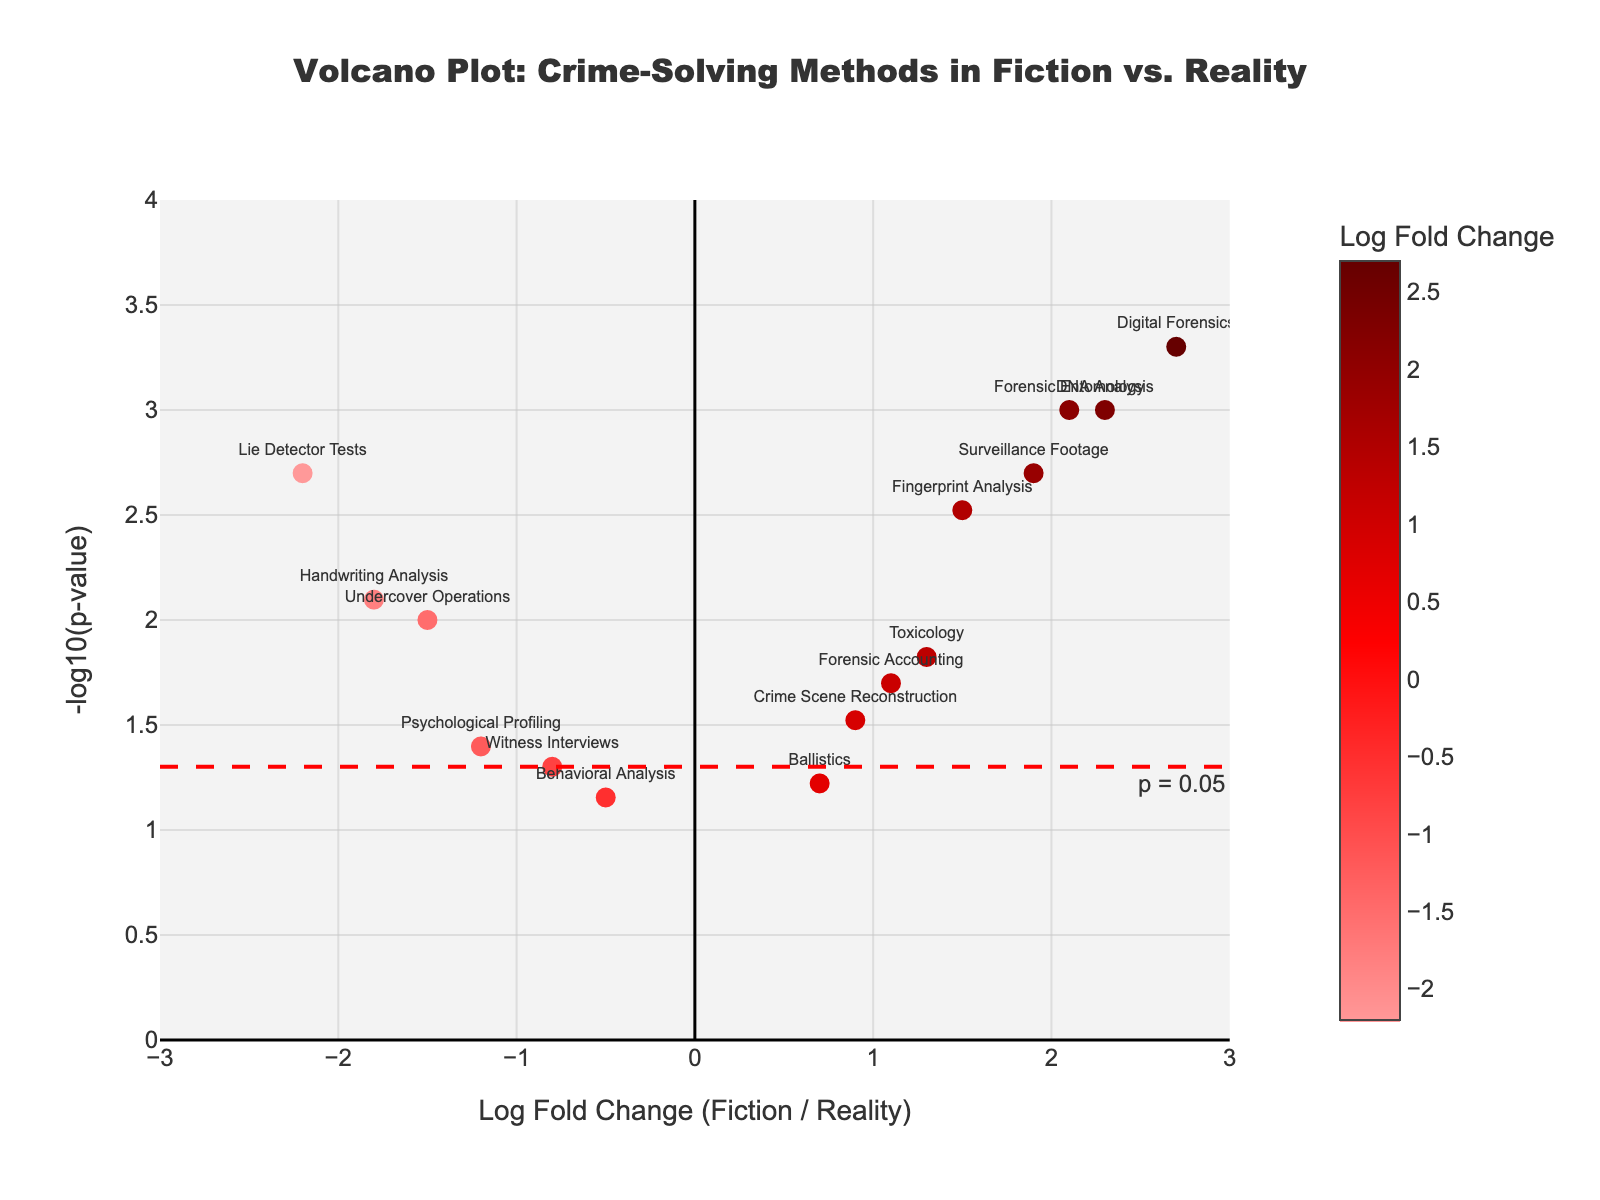What is the title of the plot? The title of the plot is displayed prominently at the top center of the figure. It reads "Volcano Plot: Crime-Solving Methods in Fiction vs. Reality".
Answer: Volcano Plot: Crime-Solving Methods in Fiction vs. Reality How many crime-solving methods are displayed in the plot? By counting the number of data points (markers) labeled with different methods on the plot, we see there are 14 different methods.
Answer: 14 Which crime-solving method has the highest log fold change? The highest log fold change can be identified by locating the data point farthest to the right on the x-axis. This corresponds to "Digital Forensics" with a log fold change of 2.7.
Answer: Digital Forensics What is the p-value threshold indicated by the horizontal line, and what does it signify? The horizontal dashed line is at y = -log10(p-value) = -log10(0.05). This equals 1.3. It signifies the cutoff for determining significant methods: values above this line are statistically significant.
Answer: 0.05 Which method is plotted with the lowest log fold change and what is its value? The lowest log fold change is observed by locating the data point farthest to the left on the x-axis, which is "Lie Detector Tests" with a log fold change of -2.2.
Answer: Lie Detector Tests, -2.2 How many methods have statistically significant p-values (p < 0.05)? By identifying the data points above the y = 1.3 line, we count the methods that have -log10(p-value) > 1.3. There are 11 such methods.
Answer: 11 Which method has the highest -log10(p-value) and what is its value? The highest -log10(p-value) is found by locating the highest data point on the y-axis, which is "Digital Forensics" with a -log10(p-value) of 3.30.
Answer: Digital Forensics, 3.30 Compare the log fold changes and significance of "Fingerprint Analysis" and "Surveillance Footage". Which is more significant and which has a higher fold change? By checking the positions of "Fingerprint Analysis" and "Surveillance Footage" on the plot:
- "Fingerprint Analysis" (1.5, 2.52)
- "Surveillance Footage" (1.9, 2.70)
"Surveillance Footage" has both a higher fold change and higher -log10(p-value), indicating greater significance.
Answer: Surveillance Footage is more significant and has a higher fold change What can be inferred about the popularity of "Psychological Profiling" and "Behavioral Analysis" in fiction compared to reality? Both "Psychological Profiling" (-1.2) and "Behavioral Analysis" (-0.5) have negative log fold changes, indicating they are more frequently used in reality than depicted in fiction.
Answer: More frequent in reality Compare the p-values of "DNA Analysis" and "Lie Detector Tests". Which method shows a lower p-value, and by how much? Convert -log10(p-value) back to p-value:
- "DNA Analysis": p-value = 10^(-3) = 0.001
- "Lie Detector Tests": p-value = 10^(-3.70) ≈ 0.002
Thus, "DNA Analysis" has a lower p-value by 0.001.
Answer: DNA Analysis, 0.001 